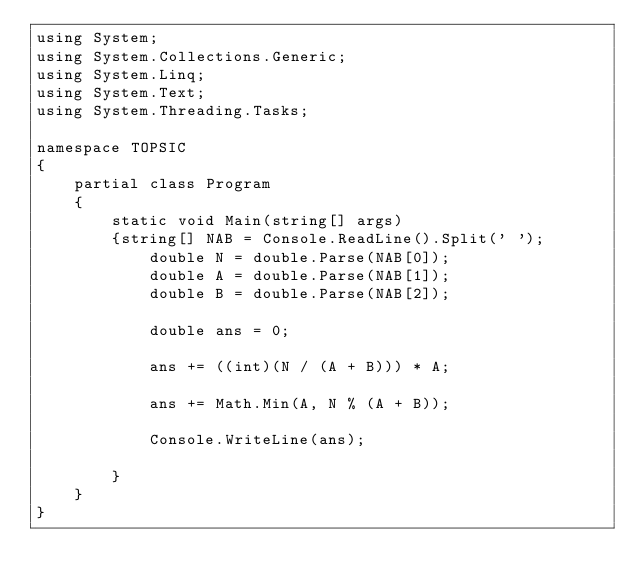<code> <loc_0><loc_0><loc_500><loc_500><_C#_>using System;
using System.Collections.Generic;
using System.Linq;
using System.Text;
using System.Threading.Tasks;

namespace TOPSIC
{
    partial class Program
    {
        static void Main(string[] args)
        {string[] NAB = Console.ReadLine().Split(' ');
            double N = double.Parse(NAB[0]);
            double A = double.Parse(NAB[1]);
            double B = double.Parse(NAB[2]);

            double ans = 0;

            ans += ((int)(N / (A + B))) * A;

            ans += Math.Min(A, N % (A + B));

            Console.WriteLine(ans);

        }
    }
}</code> 